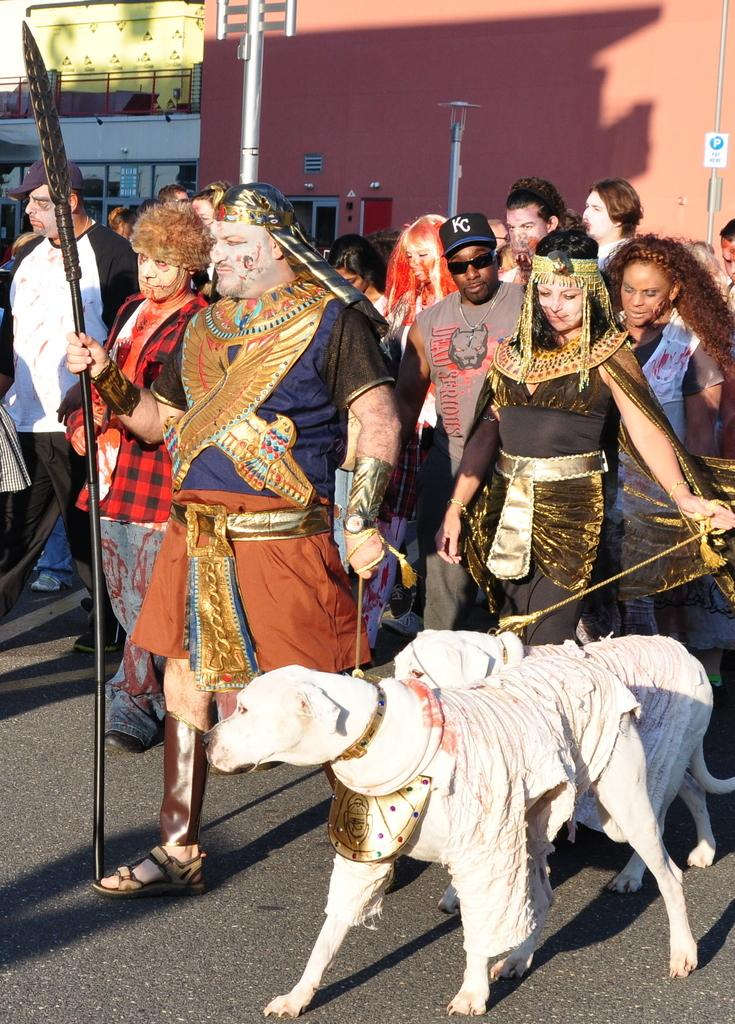What are the people in the image doing? The persons standing on the road are likely waiting or walking. What animal is present in the image? There is a dog in the image. What can be seen in the background of the image? There is a building in the background. What object is present in the image that is typically used for supporting or holding something? There is a pole in the image. What type of vegetable is being used as a spoon by the persons in the image? There is no vegetable being used as a spoon in the image; the persons are not using any utensils. 